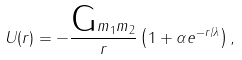<formula> <loc_0><loc_0><loc_500><loc_500>U ( r ) = - \frac { \text {G} m _ { 1 } m _ { 2 } } { r } \left ( 1 + \alpha e ^ { - r / \lambda } \right ) ,</formula> 